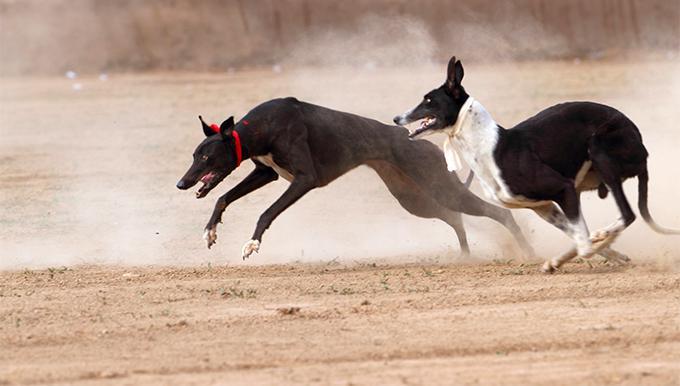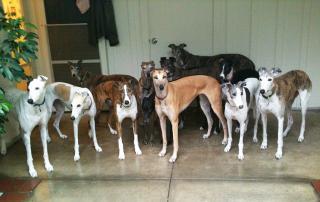The first image is the image on the left, the second image is the image on the right. Considering the images on both sides, is "Both dogs are leaning on their front legs." valid? Answer yes or no. No. The first image is the image on the left, the second image is the image on the right. For the images shown, is this caption "Each image features a hound dog posed with its front half lowered and its hind haunches raised." true? Answer yes or no. No. 